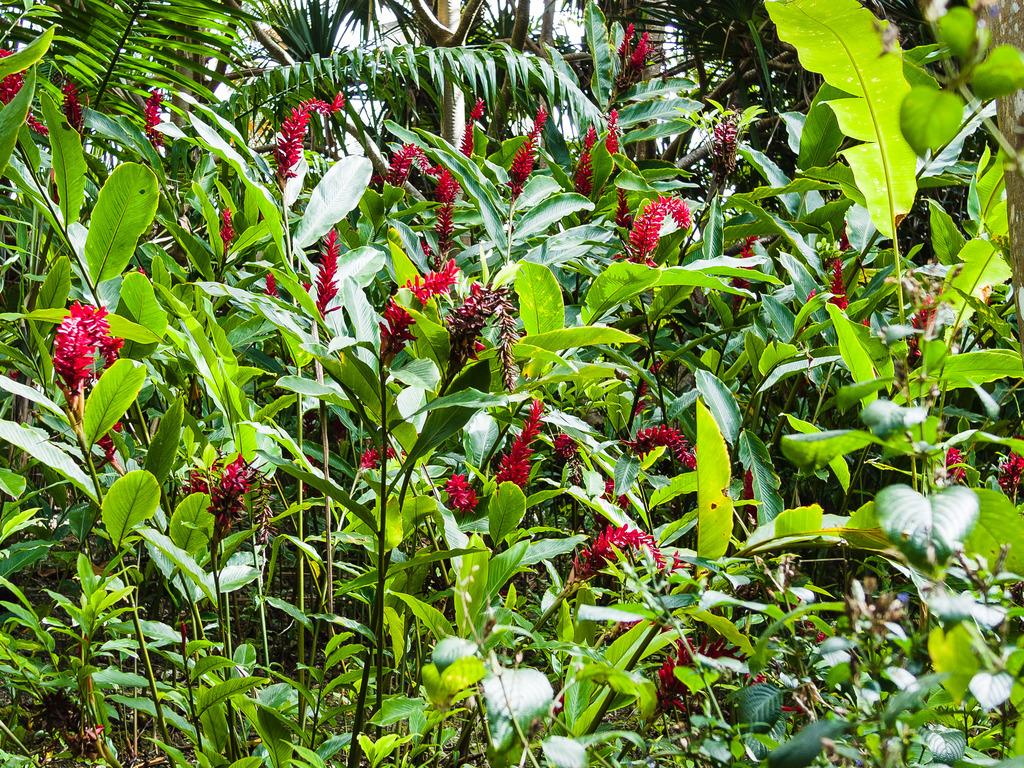What types of living organisms can be seen in the image? Plants and flowers are visible in the image. Can you describe the trees visible at the top of the image? Yes, there are trees visible at the top of the image. What type of mitten is being used by the judge in the image? There is no mitten or judge present in the image. How many fans can be seen in the image? There are no fans visible in the image. 